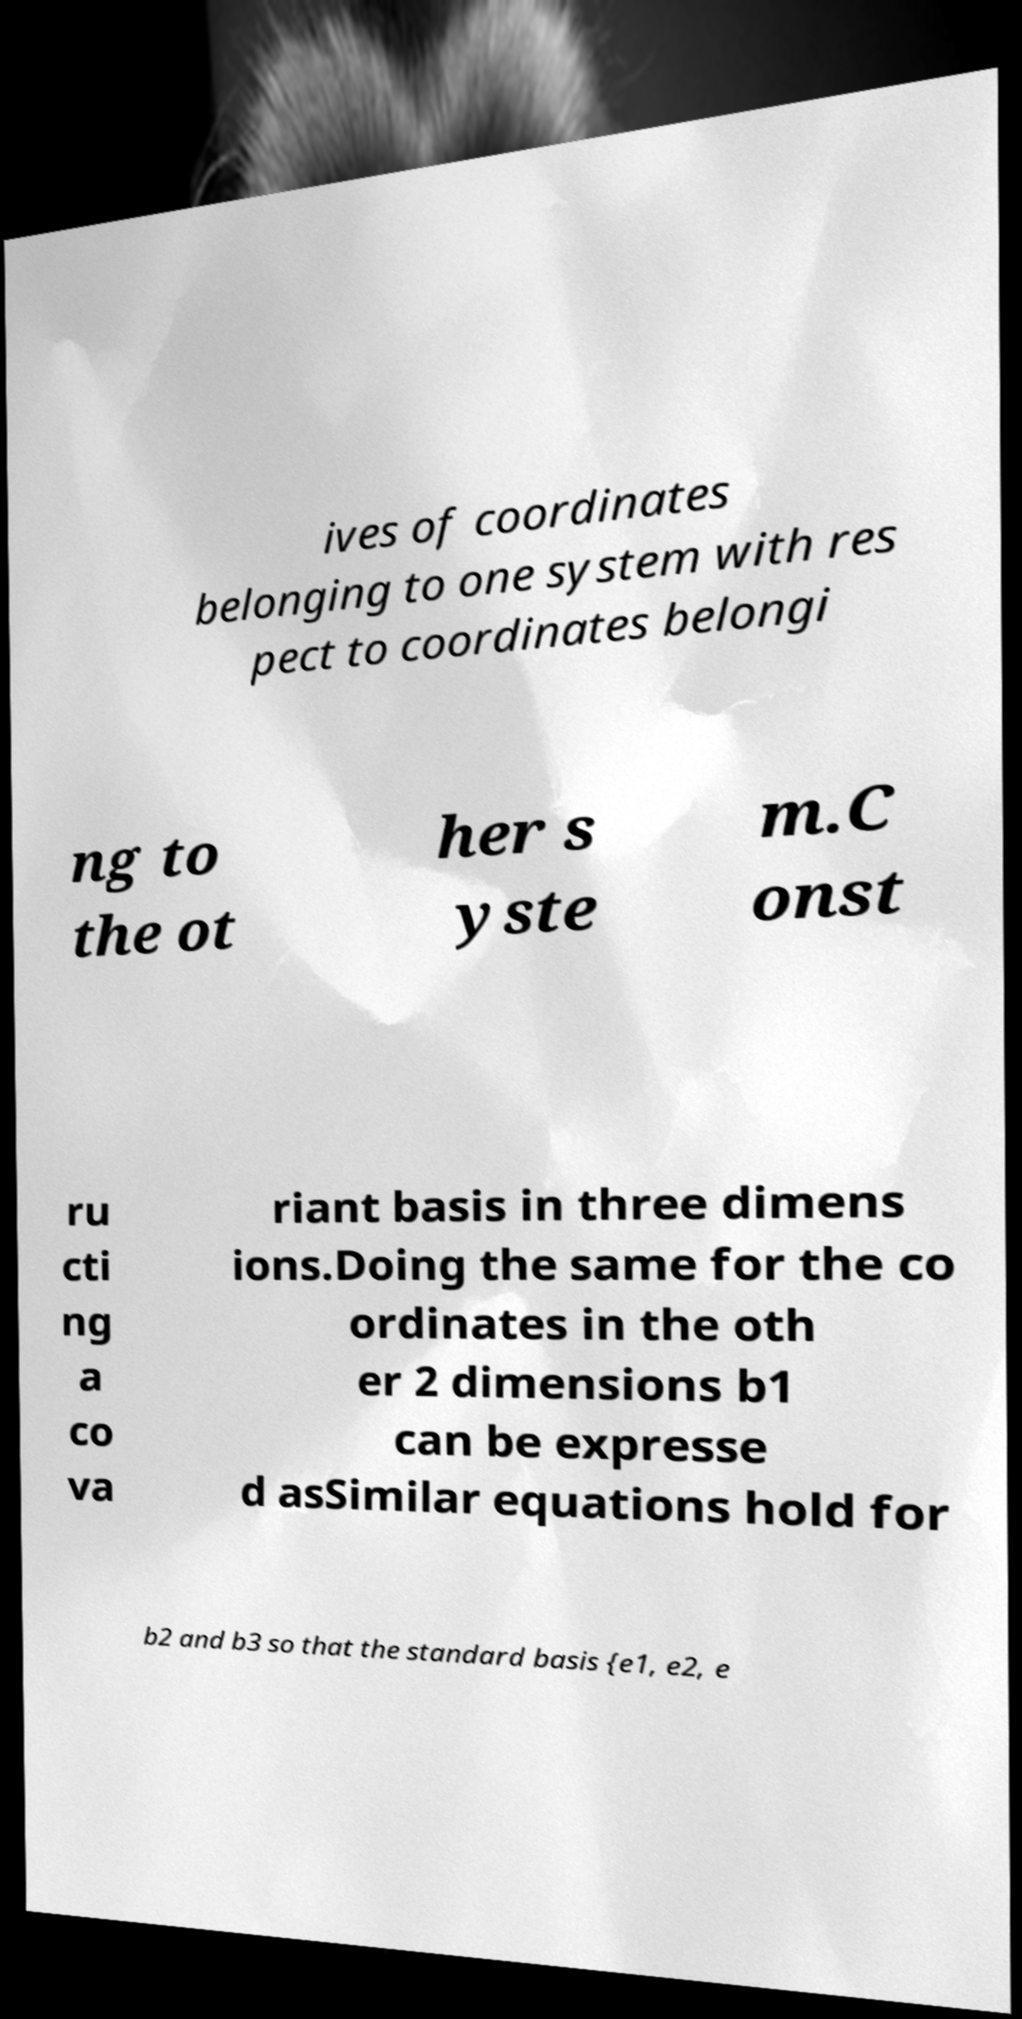Could you extract and type out the text from this image? ives of coordinates belonging to one system with res pect to coordinates belongi ng to the ot her s yste m.C onst ru cti ng a co va riant basis in three dimens ions.Doing the same for the co ordinates in the oth er 2 dimensions b1 can be expresse d asSimilar equations hold for b2 and b3 so that the standard basis {e1, e2, e 